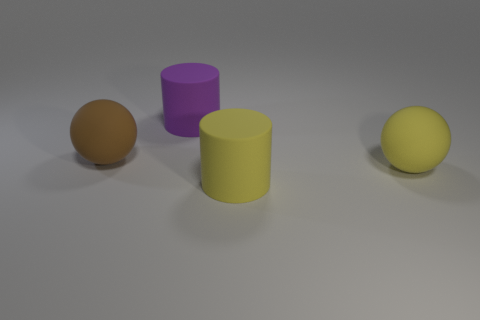The big sphere in front of the big brown thing is what color? The prominent sphere positioned in the foreground, just before the larger brown object, exhibits a vibrant yellow hue. 